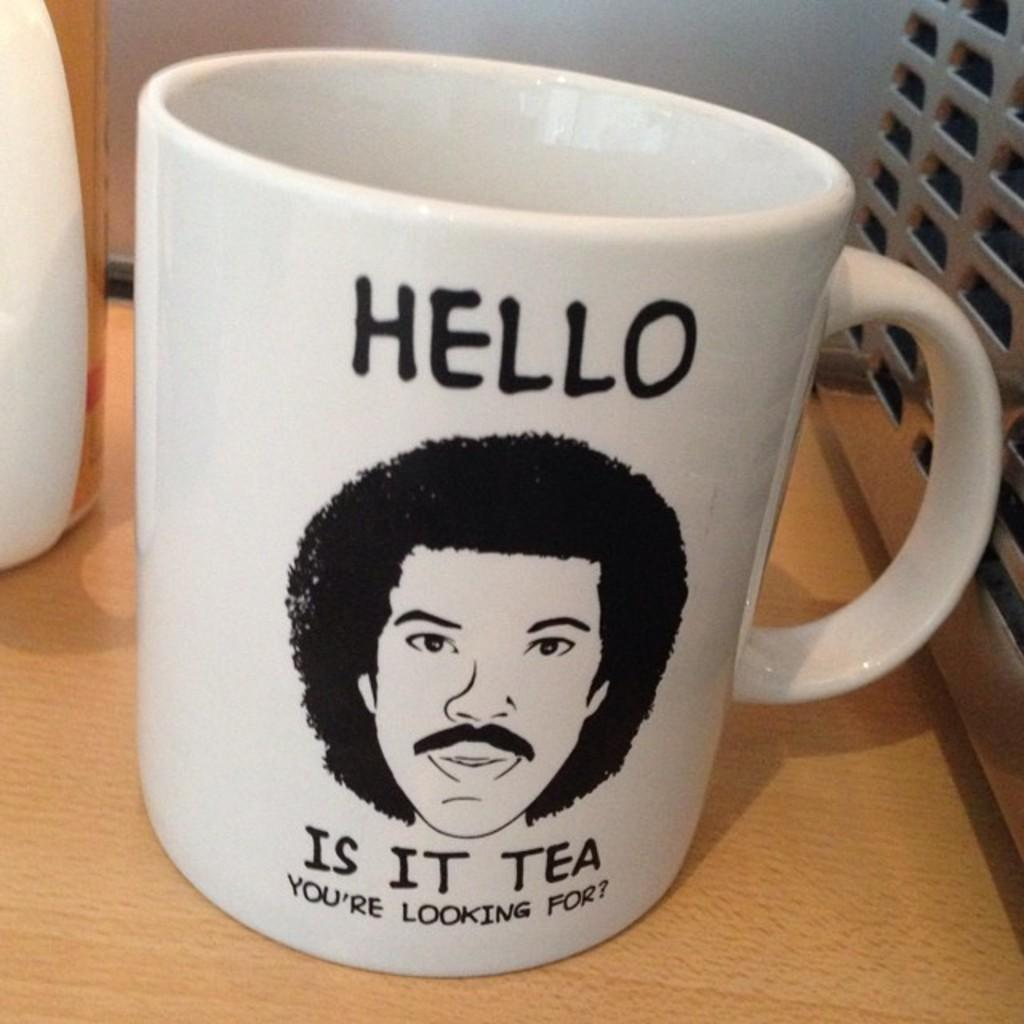What is the main object in the image? There is a mug in the image. Where is the mug placed? The mug is on a wooden platform. What is depicted on the mug? There is a picture of a person's face on the mug. Are there any words on the mug? Yes, there is writing on the mug. What else can be seen on the wooden platform? There are other objects on the wooden platform. What type of caption is written on the wrist of the person in the image? There is no wrist or person present in the image; it features a mug with a picture of a person's face and writing on it. Who is the partner of the person depicted on the mug in the image? There is no information about the person's partner in the image, as it only shows a mug with a picture of a person's face and writing on it. 